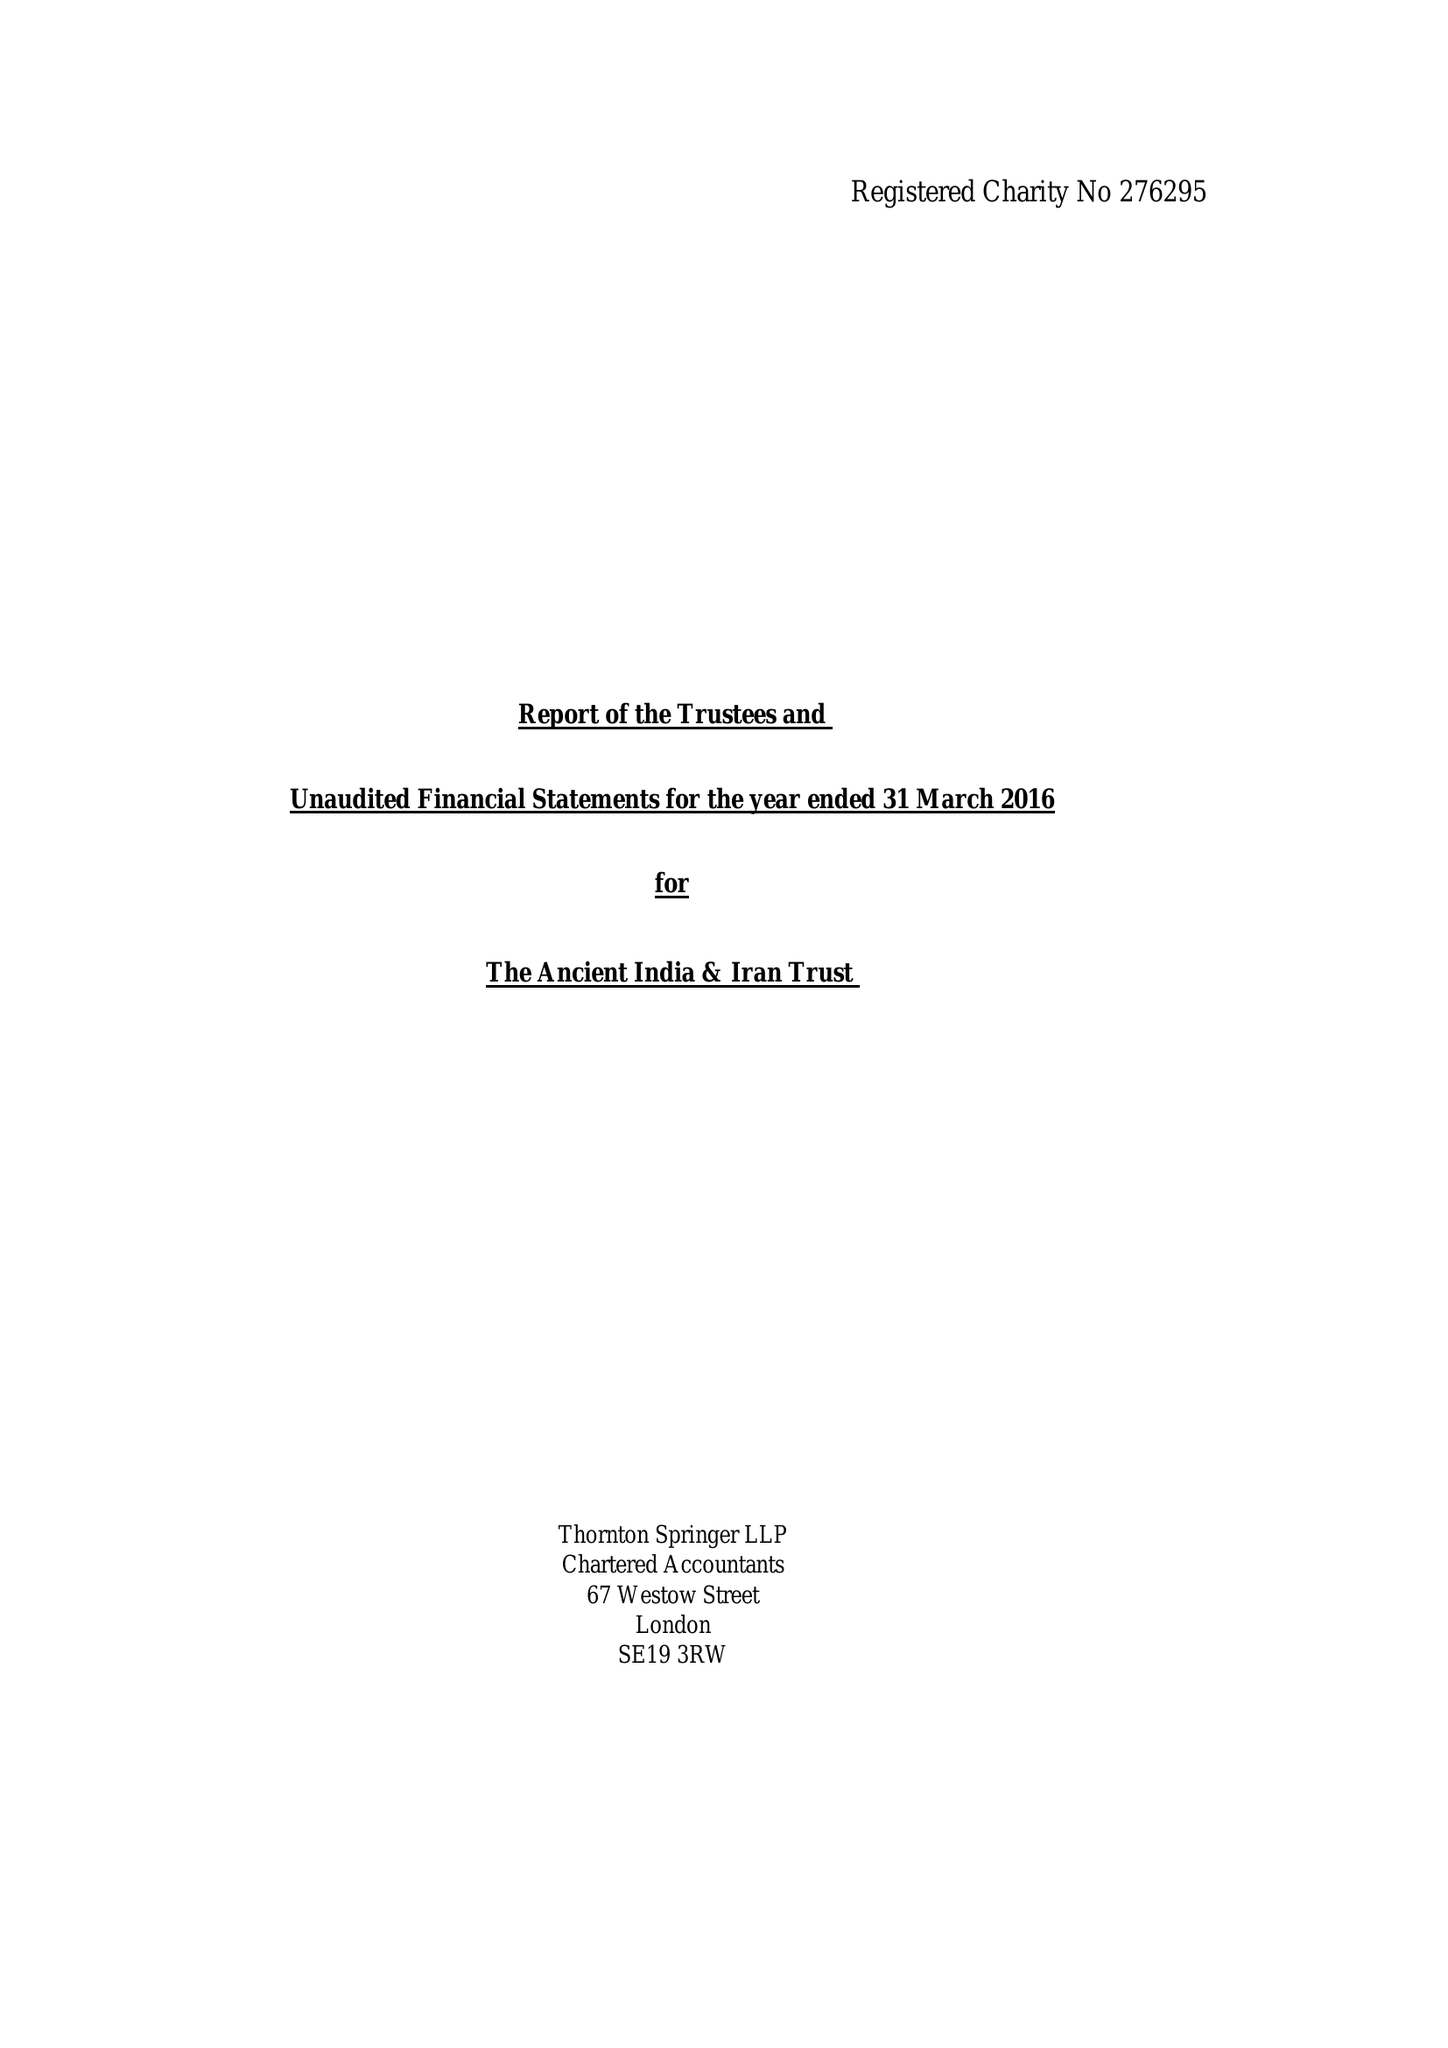What is the value for the charity_name?
Answer the question using a single word or phrase. The Ancient India and Iran Trust 